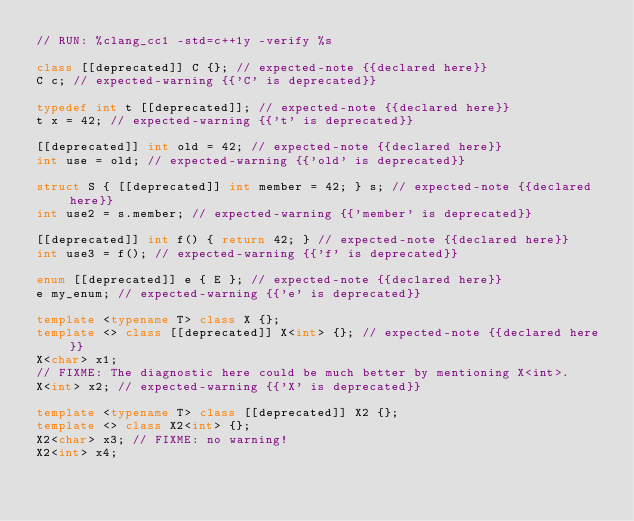<code> <loc_0><loc_0><loc_500><loc_500><_C++_>// RUN: %clang_cc1 -std=c++1y -verify %s

class [[deprecated]] C {}; // expected-note {{declared here}}
C c; // expected-warning {{'C' is deprecated}}

typedef int t [[deprecated]]; // expected-note {{declared here}}
t x = 42; // expected-warning {{'t' is deprecated}}

[[deprecated]] int old = 42; // expected-note {{declared here}}
int use = old; // expected-warning {{'old' is deprecated}}

struct S { [[deprecated]] int member = 42; } s; // expected-note {{declared here}}
int use2 = s.member; // expected-warning {{'member' is deprecated}}

[[deprecated]] int f() { return 42; } // expected-note {{declared here}}
int use3 = f(); // expected-warning {{'f' is deprecated}}

enum [[deprecated]] e { E }; // expected-note {{declared here}}
e my_enum; // expected-warning {{'e' is deprecated}}

template <typename T> class X {};
template <> class [[deprecated]] X<int> {}; // expected-note {{declared here}}
X<char> x1;
// FIXME: The diagnostic here could be much better by mentioning X<int>.
X<int> x2; // expected-warning {{'X' is deprecated}}

template <typename T> class [[deprecated]] X2 {};
template <> class X2<int> {};
X2<char> x3; // FIXME: no warning!
X2<int> x4;
</code> 